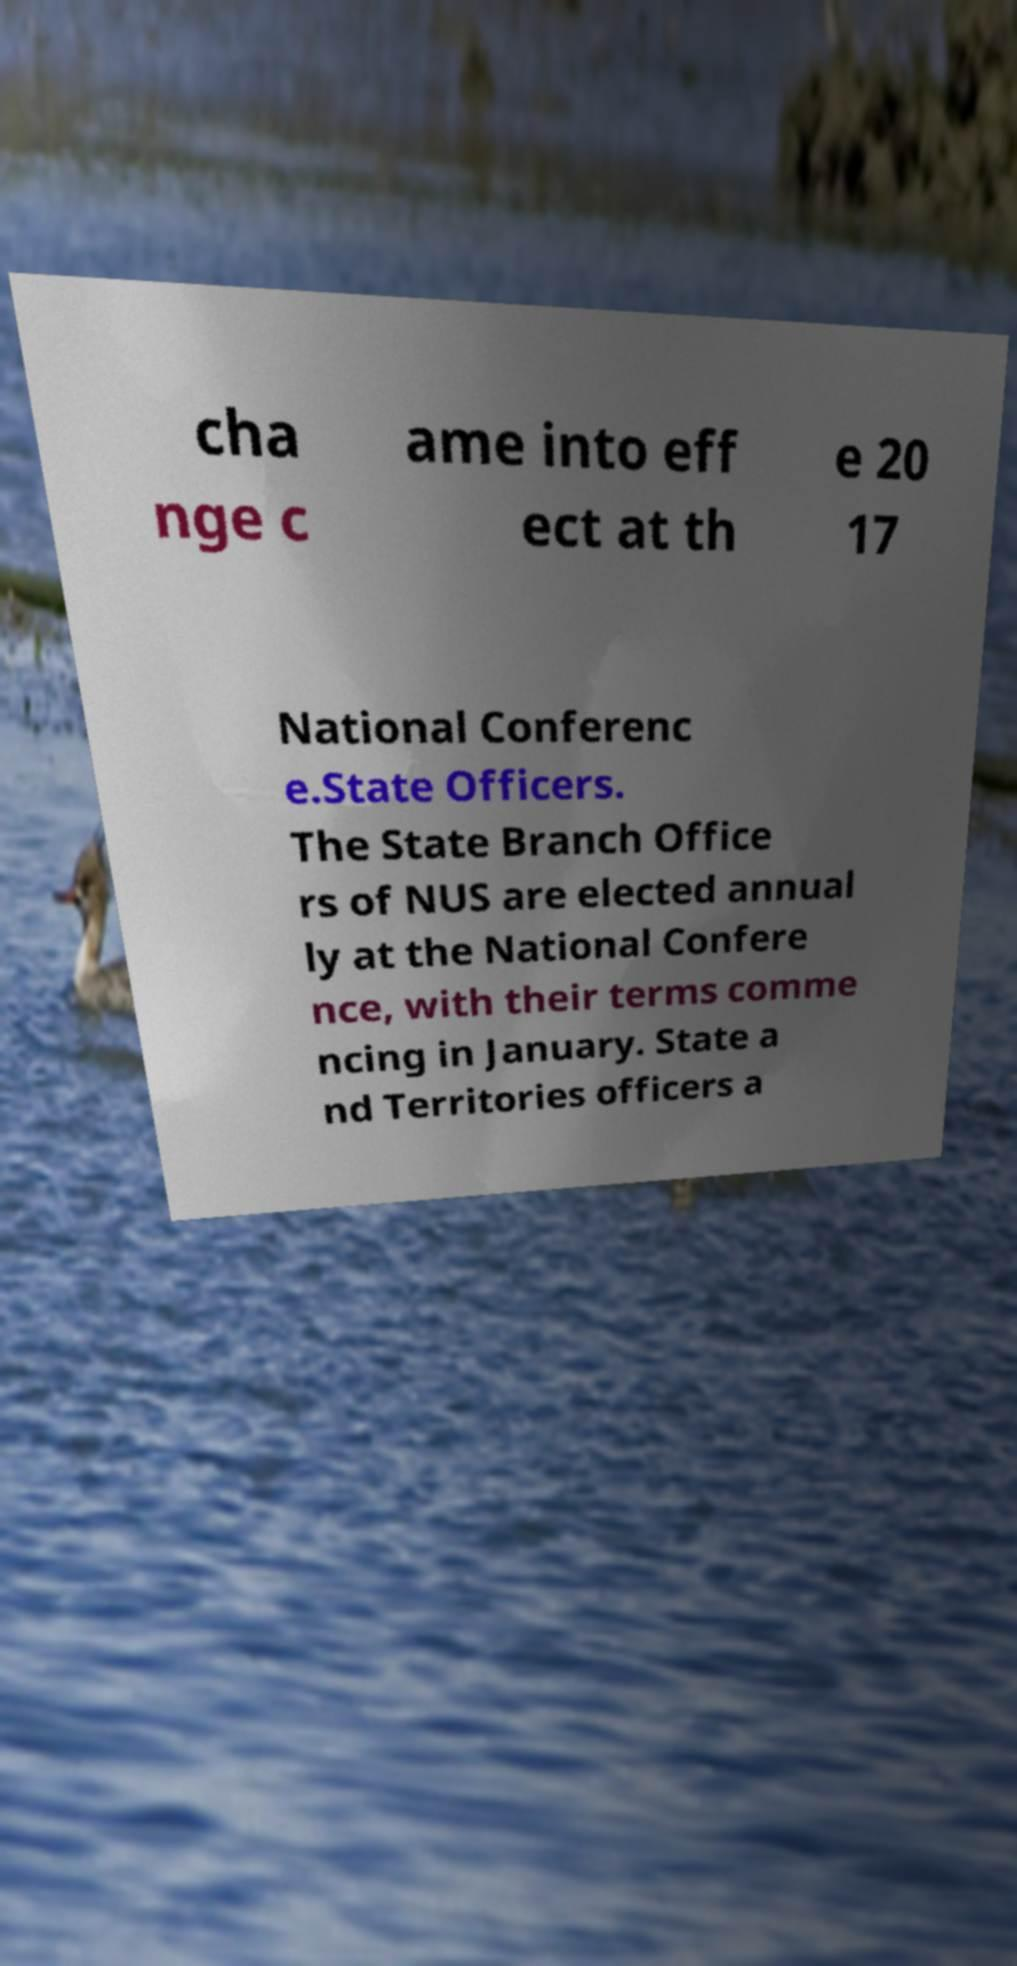Please read and relay the text visible in this image. What does it say? cha nge c ame into eff ect at th e 20 17 National Conferenc e.State Officers. The State Branch Office rs of NUS are elected annual ly at the National Confere nce, with their terms comme ncing in January. State a nd Territories officers a 